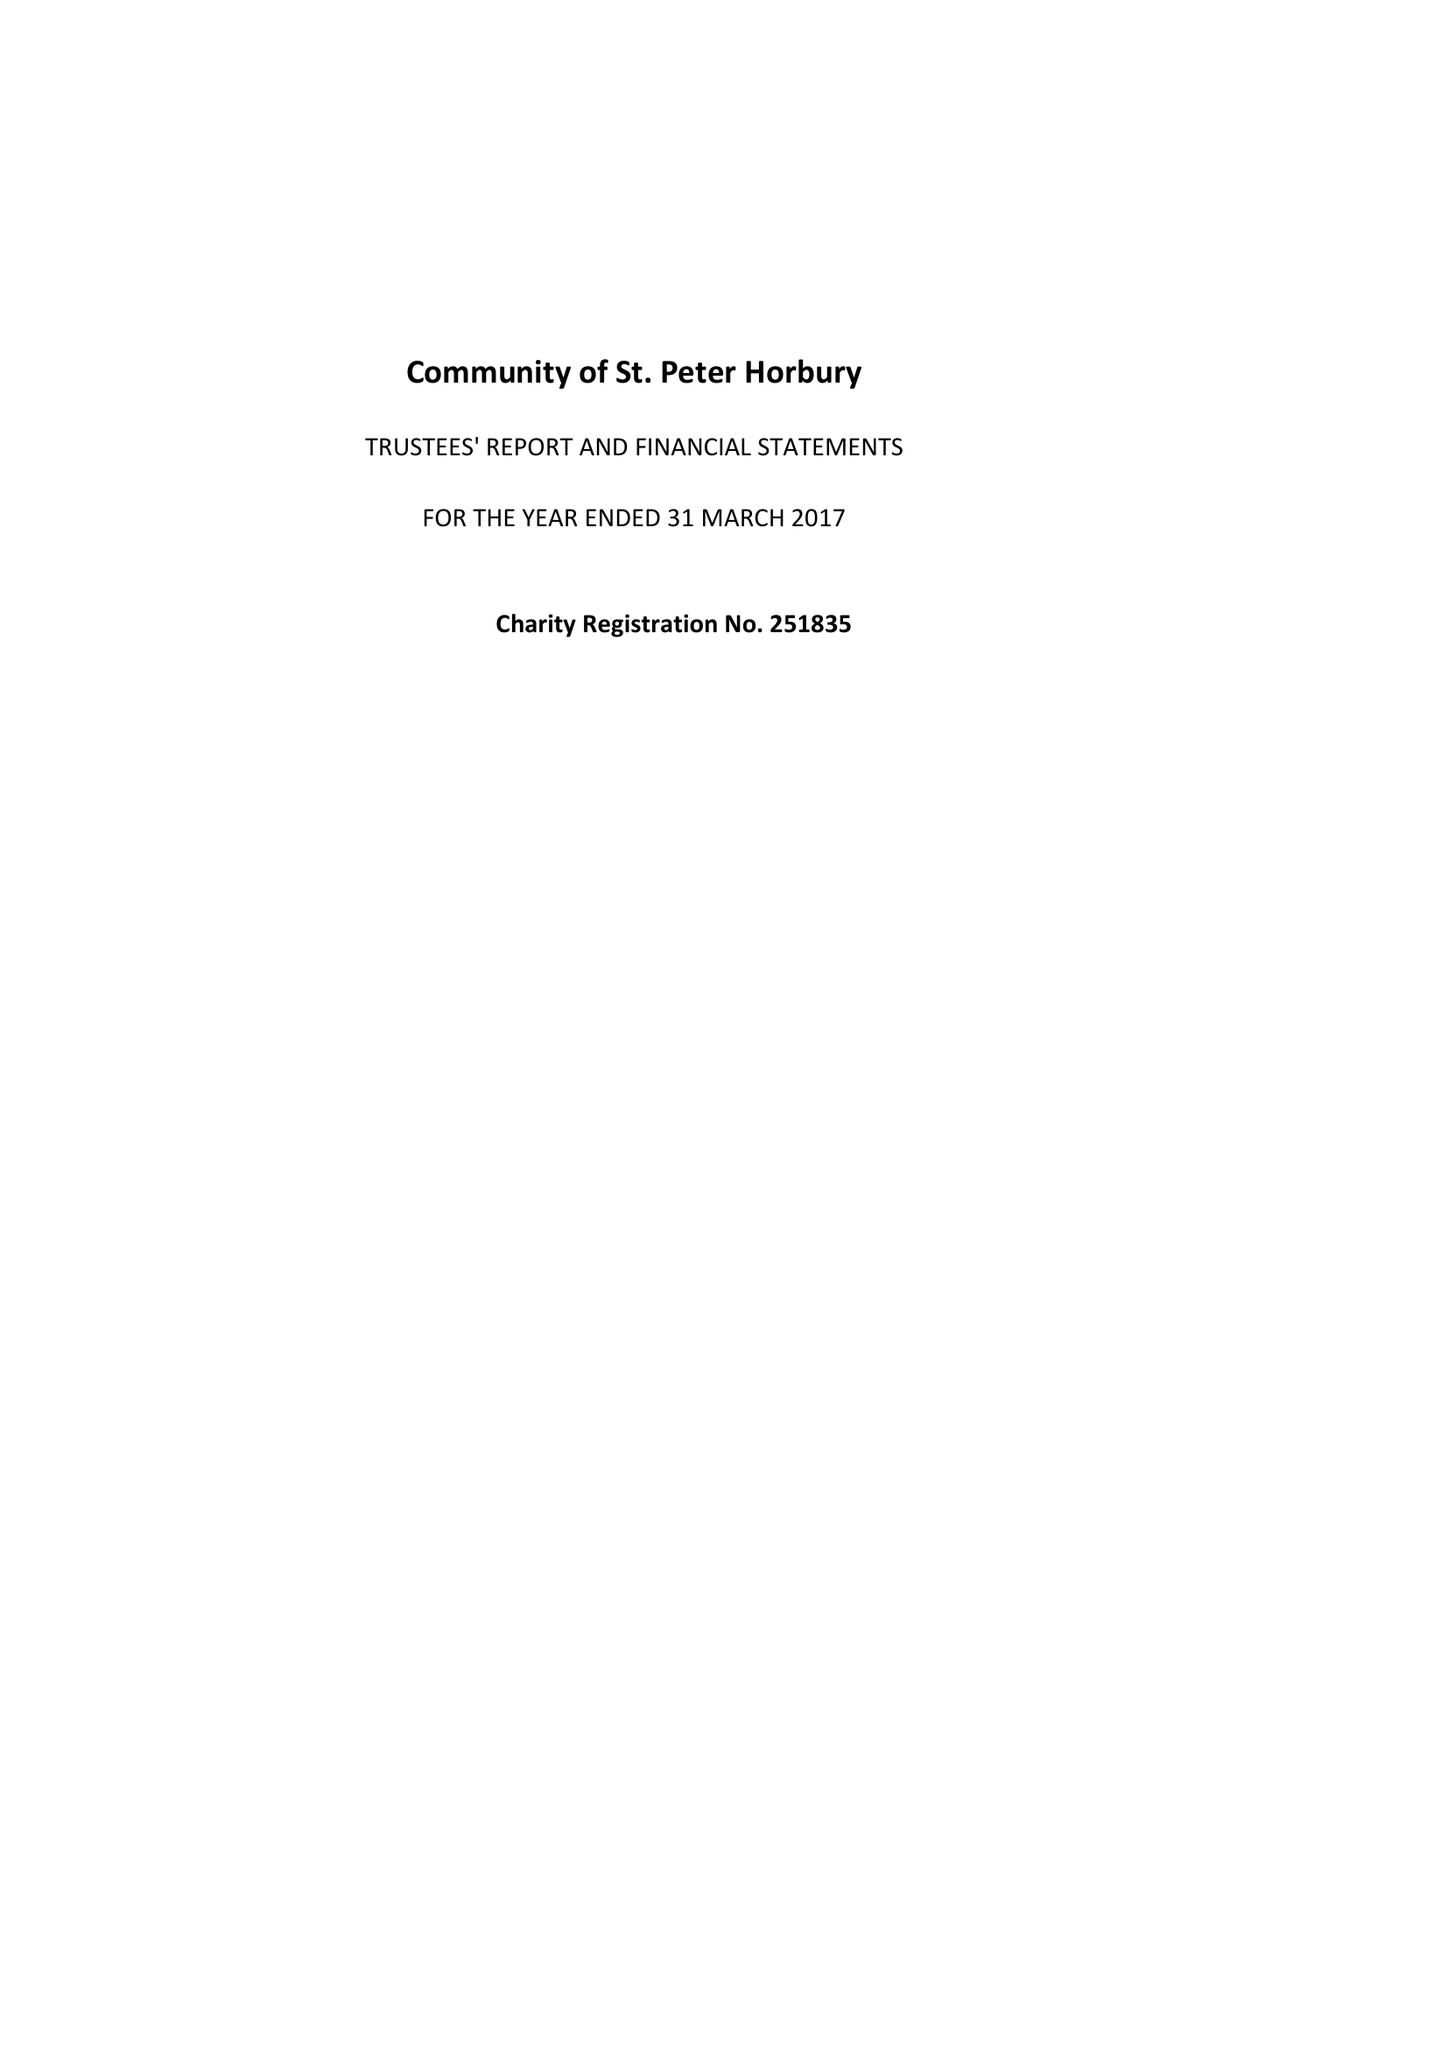What is the value for the charity_number?
Answer the question using a single word or phrase. 251835 